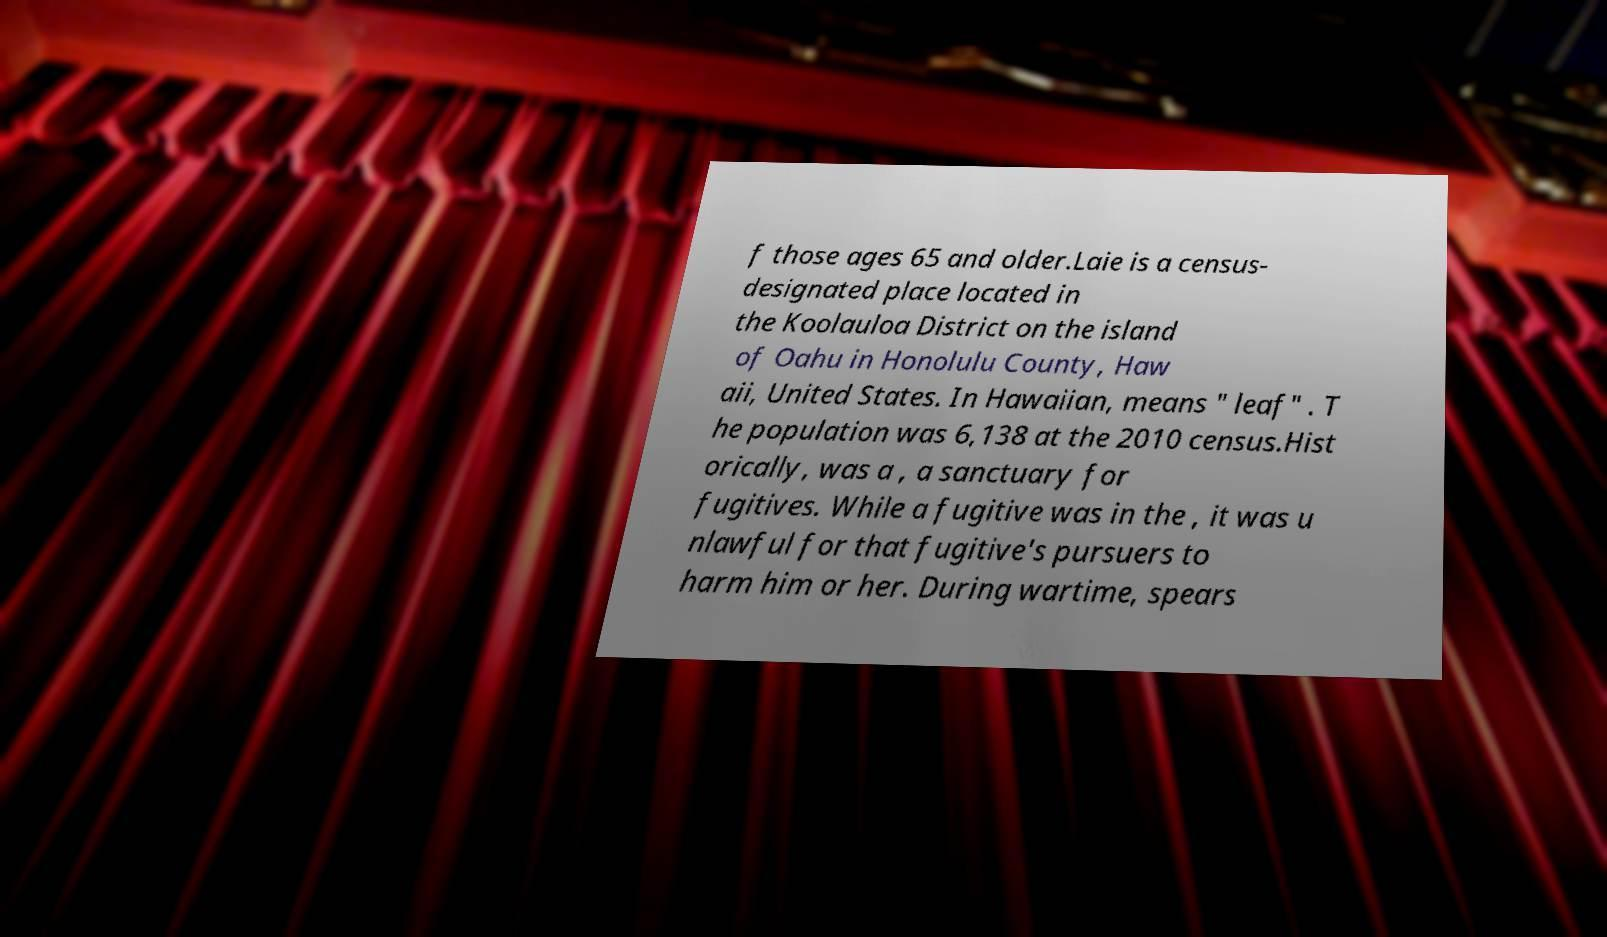What messages or text are displayed in this image? I need them in a readable, typed format. f those ages 65 and older.Laie is a census- designated place located in the Koolauloa District on the island of Oahu in Honolulu County, Haw aii, United States. In Hawaiian, means " leaf" . T he population was 6,138 at the 2010 census.Hist orically, was a , a sanctuary for fugitives. While a fugitive was in the , it was u nlawful for that fugitive's pursuers to harm him or her. During wartime, spears 